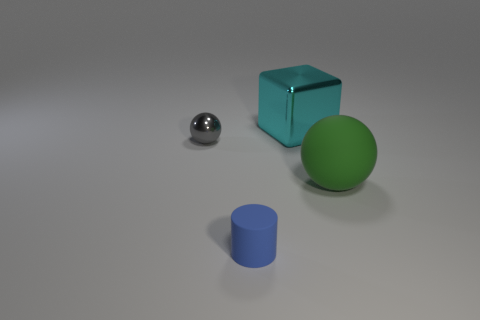The matte object behind the rubber thing that is to the left of the sphere right of the large metallic cube is what shape?
Give a very brief answer. Sphere. There is a shiny thing that is on the left side of the cyan metallic object; what number of cyan cubes are on the left side of it?
Give a very brief answer. 0. Is the shape of the small thing that is behind the green sphere the same as the metal object that is to the right of the small gray metal object?
Give a very brief answer. No. There is a cyan cube; how many large shiny cubes are behind it?
Provide a succinct answer. 0. Does the tiny object that is to the left of the blue cylinder have the same material as the blue object?
Offer a terse response. No. What is the color of the other tiny metallic object that is the same shape as the green object?
Your answer should be very brief. Gray. There is a tiny matte object; what shape is it?
Give a very brief answer. Cylinder. What number of things are tiny blue objects or small blue rubber cubes?
Your response must be concise. 1. Is the color of the small thing that is behind the blue rubber object the same as the big thing that is in front of the large cyan metallic object?
Offer a very short reply. No. How many other things are the same shape as the small shiny thing?
Your answer should be compact. 1. 